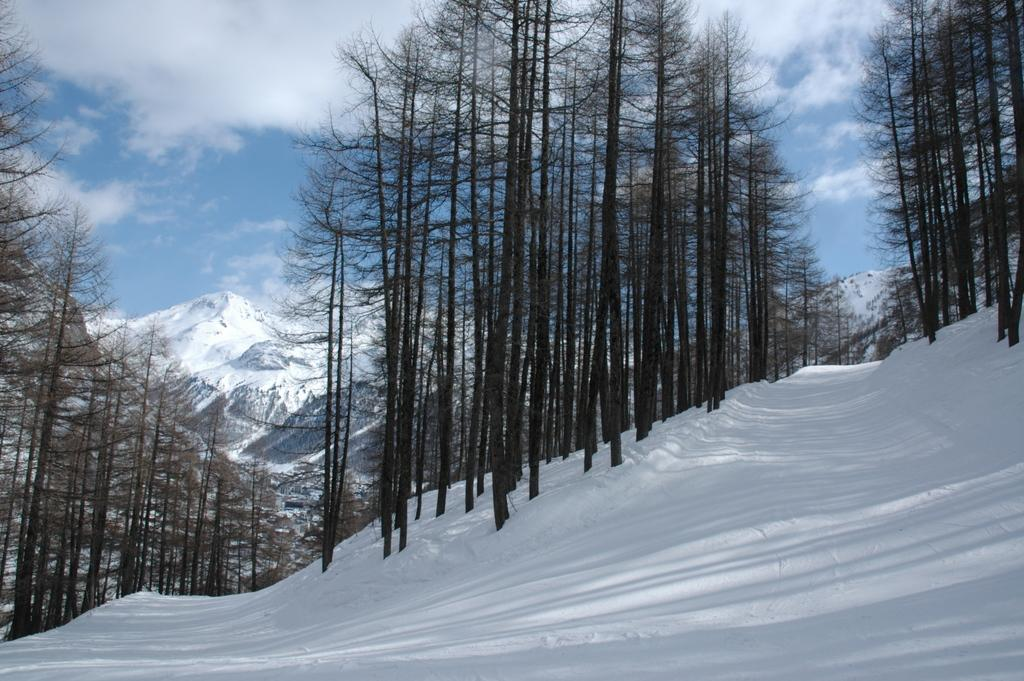What is the primary feature of the landscape in the image? There is snow in the image. What type of vegetation can be seen in the image? There are many trees in the image. What can be seen in the distance in the image? Mountains are visible in the background of the image. What is the condition of the sky in the image? Clouds and the sky are visible in the background of the image. How are the mountains in the image affected by the snow? The mountains are covered with snow. What type of silver object can be seen in the image? There is no silver object present in the image. What is the relation between the trees and the mountains in the image? The provided facts do not mention any relation between the trees and the mountains; they are simply two separate features of the landscape. 